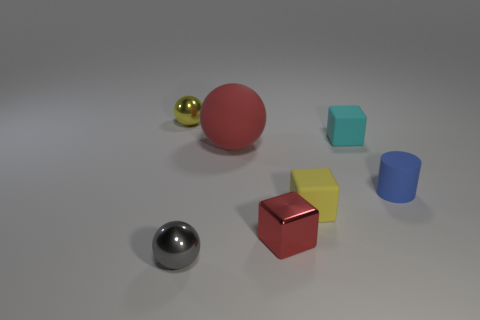Is the big matte sphere the same color as the metallic cube?
Provide a short and direct response. Yes. What is the shape of the small object that is the same color as the large object?
Offer a terse response. Cube. What size is the sphere that is the same material as the tiny blue thing?
Your response must be concise. Large. What is the size of the matte thing that is the same color as the tiny metallic cube?
Provide a succinct answer. Large. What number of other objects are there of the same shape as the cyan matte thing?
Give a very brief answer. 2. What material is the tiny yellow object in front of the tiny shiny ball behind the big matte object?
Keep it short and to the point. Rubber. Are there any other things that are the same size as the red rubber object?
Provide a short and direct response. No. Is the material of the tiny cyan cube the same as the yellow object that is on the left side of the red metal object?
Give a very brief answer. No. There is a object that is on the left side of the big red rubber object and in front of the small blue cylinder; what material is it?
Your answer should be very brief. Metal. The small metal thing behind the small yellow object that is right of the gray thing is what color?
Give a very brief answer. Yellow. 